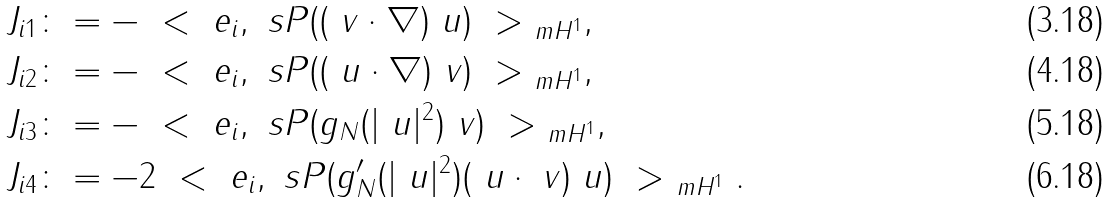Convert formula to latex. <formula><loc_0><loc_0><loc_500><loc_500>J _ { i 1 } & \colon = - \ < \ e _ { i } , \ s P ( ( \ v \cdot \nabla ) \ u ) \ > _ { \ m H ^ { 1 } } , \\ J _ { i 2 } & \colon = - \ < \ e _ { i } , \ s P ( ( \ u \cdot \nabla ) \ v ) \ > _ { \ m H ^ { 1 } } , \\ J _ { i 3 } & \colon = - \ < \ e _ { i } , \ s P ( g _ { N } ( | \ u | ^ { 2 } ) \ v ) \ > _ { \ m H ^ { 1 } } , \\ J _ { i 4 } & \colon = - 2 \ < \ e _ { i } , \ s P ( g ^ { \prime } _ { N } ( | \ u | ^ { 2 } ) ( \ u \cdot \ v ) \ u ) \ > _ { \ m H ^ { 1 } } .</formula> 